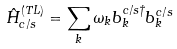Convert formula to latex. <formula><loc_0><loc_0><loc_500><loc_500>\hat { H } _ { c / s } ^ { ( T L ) } = \sum _ { k } \omega _ { k } b _ { k } ^ { c / s \dagger } b _ { k } ^ { c / s }</formula> 